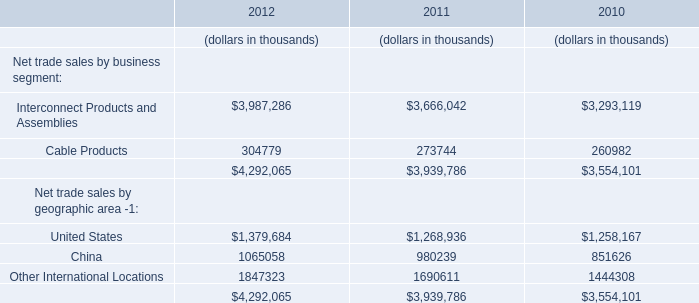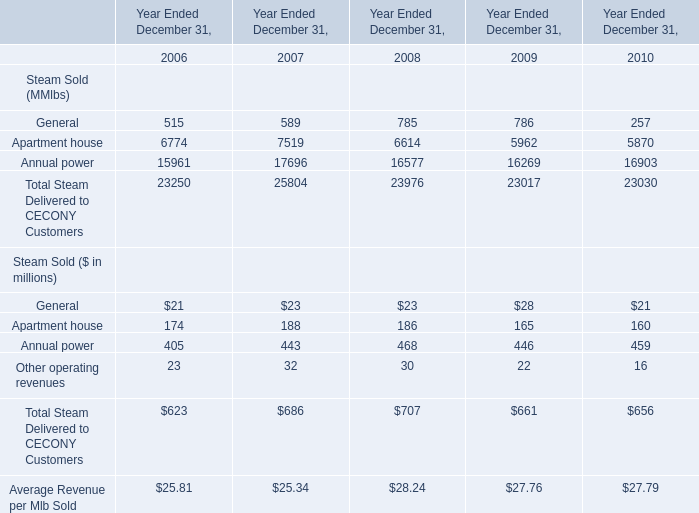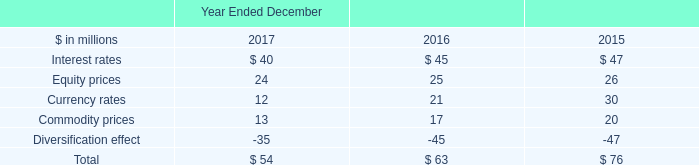Does Apartment house keeps increasing each year between 2007 and 2008? 
Answer: No. 